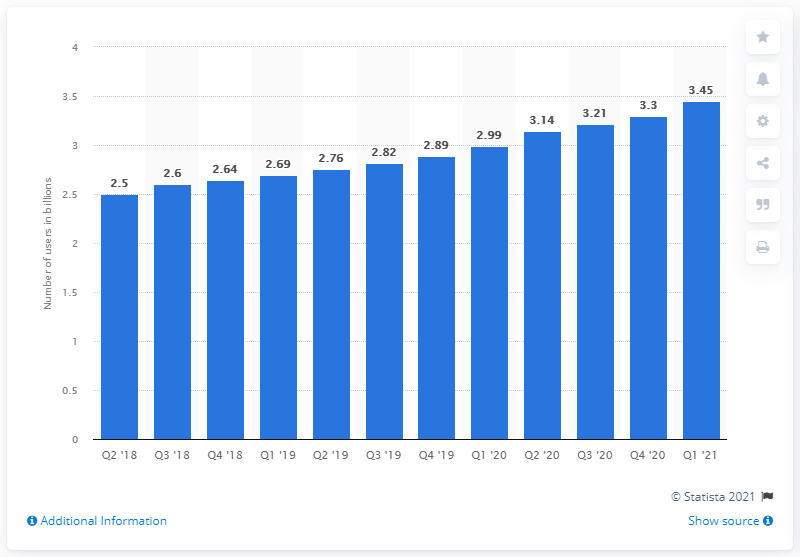Indicate a few pertinent items in this graphic. As of last year, an estimated 3.45 billion people worldwide used at least one of Facebook's core products on a monthly basis. 